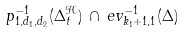Convert formula to latex. <formula><loc_0><loc_0><loc_500><loc_500>p _ { 1 , d _ { 1 } , d _ { 2 } } ^ { - 1 } ( \Delta ^ { \mathcal { H } } _ { t } ) \, \cap \, e v ^ { - 1 } _ { k _ { 1 } + 1 , 1 } ( \Delta )</formula> 